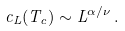Convert formula to latex. <formula><loc_0><loc_0><loc_500><loc_500>c _ { L } ( T _ { c } ) \sim L ^ { \alpha / \nu } \, .</formula> 